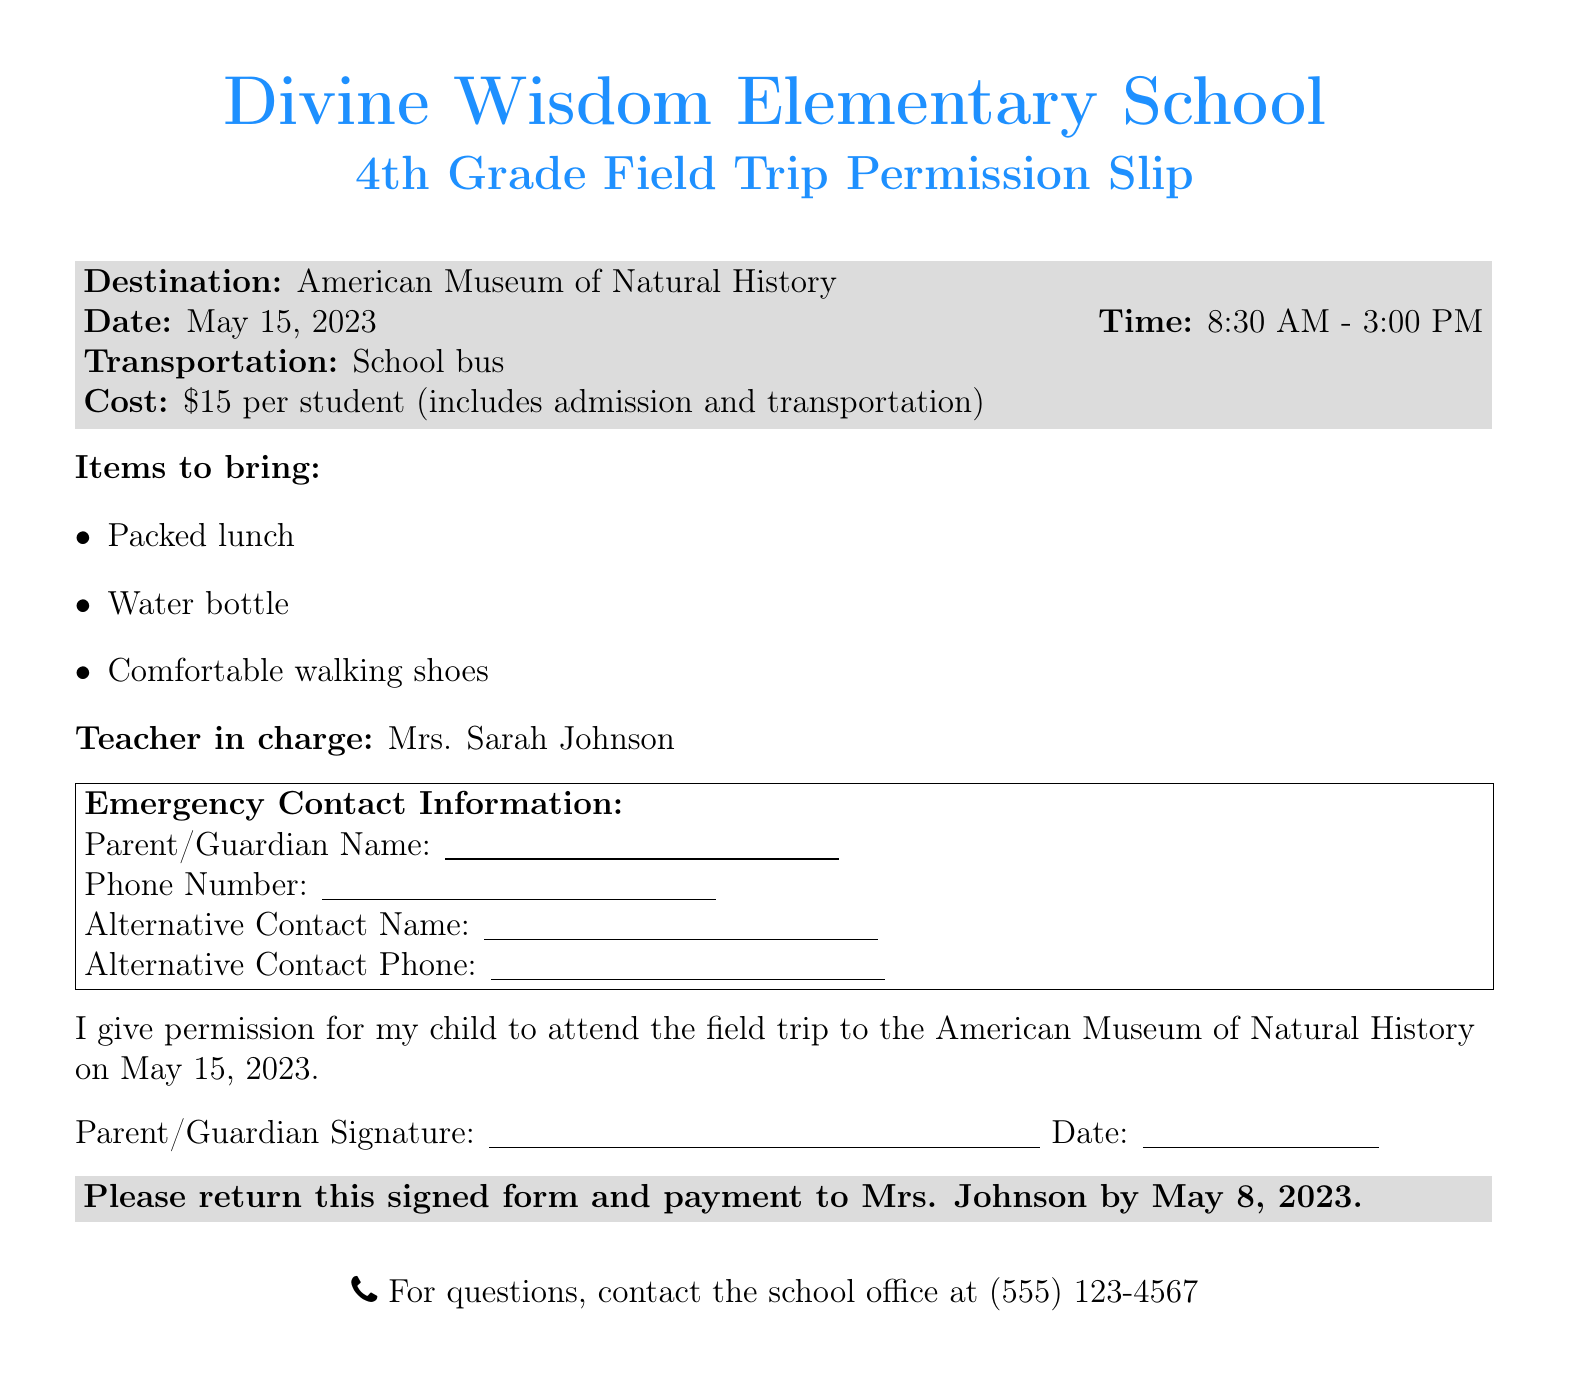What is the destination of the field trip? The destination is listed clearly at the top section of the document.
Answer: American Museum of Natural History What is the date of the field trip? The date is stated in the same section as the destination information.
Answer: May 15, 2023 What is the cost per student? The cost is mentioned directly in the details about the trip.
Answer: $15 Who is the teacher in charge of the trip? The teacher's name is provided in a specific segment of the document.
Answer: Mrs. Sarah Johnson What items should students bring? A list of items is provided under a separate section specifically outlining what to bring.
Answer: Packed lunch, Water bottle, Comfortable walking shoes What is the deadline to return the signed form? The deadline is clearly stated in the last section of the document.
Answer: May 8, 2023 Why do parents need to provide alternative contact information? This information is typically required for emergency situations during the trip, as indicated in the document’s emergency contact section.
Answer: For emergencies What mode of transportation will be used for the trip? The document specifies the transportation method for the field trip under the details section.
Answer: School bus What is the phone number for questions? The contact number is provided at the bottom of the document for inquiries.
Answer: (555) 123-4567 